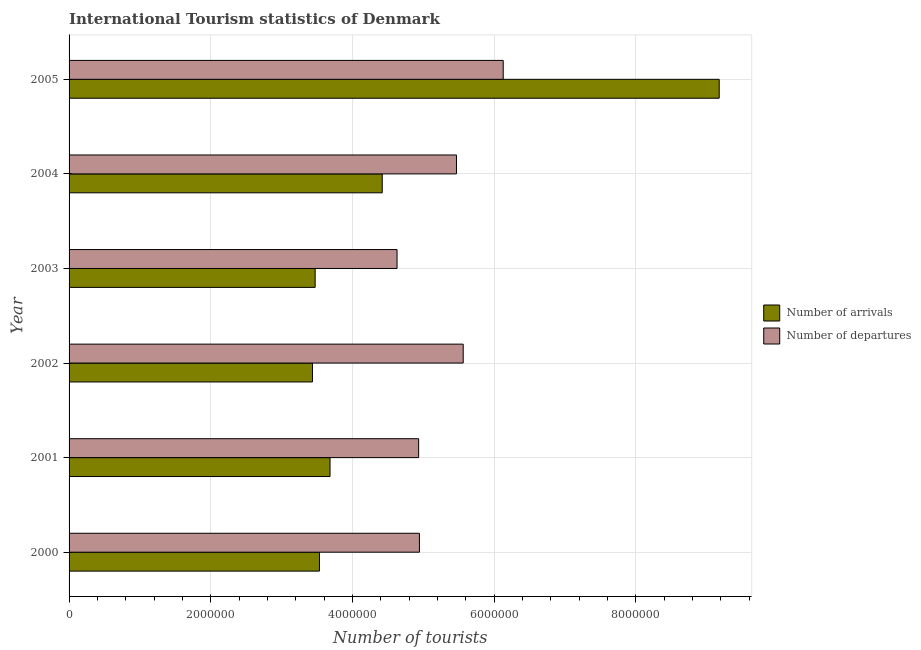How many different coloured bars are there?
Give a very brief answer. 2. Are the number of bars on each tick of the Y-axis equal?
Provide a succinct answer. Yes. What is the label of the 6th group of bars from the top?
Provide a succinct answer. 2000. What is the number of tourist departures in 2003?
Ensure brevity in your answer.  4.63e+06. Across all years, what is the maximum number of tourist arrivals?
Give a very brief answer. 9.18e+06. Across all years, what is the minimum number of tourist arrivals?
Offer a terse response. 3.44e+06. In which year was the number of tourist arrivals minimum?
Your answer should be compact. 2002. What is the total number of tourist arrivals in the graph?
Provide a short and direct response. 2.77e+07. What is the difference between the number of tourist departures in 2001 and that in 2002?
Your answer should be very brief. -6.29e+05. What is the difference between the number of tourist arrivals in 2005 and the number of tourist departures in 2003?
Offer a very short reply. 4.55e+06. What is the average number of tourist arrivals per year?
Make the answer very short. 4.62e+06. In the year 2004, what is the difference between the number of tourist departures and number of tourist arrivals?
Provide a short and direct response. 1.05e+06. What is the ratio of the number of tourist departures in 2000 to that in 2002?
Keep it short and to the point. 0.89. Is the number of tourist arrivals in 2000 less than that in 2003?
Your answer should be very brief. No. Is the difference between the number of tourist departures in 2000 and 2004 greater than the difference between the number of tourist arrivals in 2000 and 2004?
Offer a terse response. Yes. What is the difference between the highest and the second highest number of tourist departures?
Your response must be concise. 5.65e+05. What is the difference between the highest and the lowest number of tourist departures?
Give a very brief answer. 1.50e+06. What does the 1st bar from the top in 2000 represents?
Provide a short and direct response. Number of departures. What does the 2nd bar from the bottom in 2001 represents?
Provide a short and direct response. Number of departures. Are all the bars in the graph horizontal?
Ensure brevity in your answer.  Yes. Are the values on the major ticks of X-axis written in scientific E-notation?
Make the answer very short. No. Does the graph contain any zero values?
Offer a very short reply. No. Does the graph contain grids?
Keep it short and to the point. Yes. What is the title of the graph?
Your answer should be compact. International Tourism statistics of Denmark. What is the label or title of the X-axis?
Keep it short and to the point. Number of tourists. What is the Number of tourists of Number of arrivals in 2000?
Give a very brief answer. 3.54e+06. What is the Number of tourists of Number of departures in 2000?
Offer a very short reply. 4.95e+06. What is the Number of tourists in Number of arrivals in 2001?
Provide a short and direct response. 3.68e+06. What is the Number of tourists in Number of departures in 2001?
Offer a terse response. 4.94e+06. What is the Number of tourists in Number of arrivals in 2002?
Keep it short and to the point. 3.44e+06. What is the Number of tourists in Number of departures in 2002?
Make the answer very short. 5.56e+06. What is the Number of tourists of Number of arrivals in 2003?
Provide a short and direct response. 3.47e+06. What is the Number of tourists of Number of departures in 2003?
Your response must be concise. 4.63e+06. What is the Number of tourists in Number of arrivals in 2004?
Provide a short and direct response. 4.42e+06. What is the Number of tourists in Number of departures in 2004?
Make the answer very short. 5.47e+06. What is the Number of tourists in Number of arrivals in 2005?
Offer a very short reply. 9.18e+06. What is the Number of tourists of Number of departures in 2005?
Provide a short and direct response. 6.13e+06. Across all years, what is the maximum Number of tourists of Number of arrivals?
Provide a succinct answer. 9.18e+06. Across all years, what is the maximum Number of tourists in Number of departures?
Your response must be concise. 6.13e+06. Across all years, what is the minimum Number of tourists in Number of arrivals?
Make the answer very short. 3.44e+06. Across all years, what is the minimum Number of tourists in Number of departures?
Provide a succinct answer. 4.63e+06. What is the total Number of tourists in Number of arrivals in the graph?
Provide a succinct answer. 2.77e+07. What is the total Number of tourists of Number of departures in the graph?
Ensure brevity in your answer.  3.17e+07. What is the difference between the Number of tourists of Number of arrivals in 2000 and that in 2001?
Offer a very short reply. -1.49e+05. What is the difference between the Number of tourists of Number of departures in 2000 and that in 2001?
Ensure brevity in your answer.  1.10e+04. What is the difference between the Number of tourists of Number of arrivals in 2000 and that in 2002?
Provide a succinct answer. 9.90e+04. What is the difference between the Number of tourists of Number of departures in 2000 and that in 2002?
Keep it short and to the point. -6.18e+05. What is the difference between the Number of tourists in Number of arrivals in 2000 and that in 2003?
Provide a short and direct response. 6.10e+04. What is the difference between the Number of tourists of Number of departures in 2000 and that in 2003?
Provide a succinct answer. 3.16e+05. What is the difference between the Number of tourists in Number of arrivals in 2000 and that in 2004?
Give a very brief answer. -8.86e+05. What is the difference between the Number of tourists of Number of departures in 2000 and that in 2004?
Ensure brevity in your answer.  -5.23e+05. What is the difference between the Number of tourists of Number of arrivals in 2000 and that in 2005?
Ensure brevity in your answer.  -5.64e+06. What is the difference between the Number of tourists of Number of departures in 2000 and that in 2005?
Keep it short and to the point. -1.18e+06. What is the difference between the Number of tourists of Number of arrivals in 2001 and that in 2002?
Your response must be concise. 2.48e+05. What is the difference between the Number of tourists in Number of departures in 2001 and that in 2002?
Your response must be concise. -6.29e+05. What is the difference between the Number of tourists in Number of departures in 2001 and that in 2003?
Ensure brevity in your answer.  3.05e+05. What is the difference between the Number of tourists in Number of arrivals in 2001 and that in 2004?
Offer a terse response. -7.37e+05. What is the difference between the Number of tourists in Number of departures in 2001 and that in 2004?
Keep it short and to the point. -5.34e+05. What is the difference between the Number of tourists of Number of arrivals in 2001 and that in 2005?
Offer a terse response. -5.49e+06. What is the difference between the Number of tourists in Number of departures in 2001 and that in 2005?
Offer a terse response. -1.19e+06. What is the difference between the Number of tourists in Number of arrivals in 2002 and that in 2003?
Offer a terse response. -3.80e+04. What is the difference between the Number of tourists in Number of departures in 2002 and that in 2003?
Your answer should be compact. 9.34e+05. What is the difference between the Number of tourists in Number of arrivals in 2002 and that in 2004?
Give a very brief answer. -9.85e+05. What is the difference between the Number of tourists of Number of departures in 2002 and that in 2004?
Provide a short and direct response. 9.50e+04. What is the difference between the Number of tourists of Number of arrivals in 2002 and that in 2005?
Your answer should be compact. -5.74e+06. What is the difference between the Number of tourists of Number of departures in 2002 and that in 2005?
Offer a terse response. -5.65e+05. What is the difference between the Number of tourists in Number of arrivals in 2003 and that in 2004?
Give a very brief answer. -9.47e+05. What is the difference between the Number of tourists of Number of departures in 2003 and that in 2004?
Ensure brevity in your answer.  -8.39e+05. What is the difference between the Number of tourists in Number of arrivals in 2003 and that in 2005?
Keep it short and to the point. -5.70e+06. What is the difference between the Number of tourists of Number of departures in 2003 and that in 2005?
Offer a very short reply. -1.50e+06. What is the difference between the Number of tourists in Number of arrivals in 2004 and that in 2005?
Ensure brevity in your answer.  -4.76e+06. What is the difference between the Number of tourists in Number of departures in 2004 and that in 2005?
Offer a very short reply. -6.60e+05. What is the difference between the Number of tourists in Number of arrivals in 2000 and the Number of tourists in Number of departures in 2001?
Your response must be concise. -1.40e+06. What is the difference between the Number of tourists in Number of arrivals in 2000 and the Number of tourists in Number of departures in 2002?
Ensure brevity in your answer.  -2.03e+06. What is the difference between the Number of tourists in Number of arrivals in 2000 and the Number of tourists in Number of departures in 2003?
Give a very brief answer. -1.10e+06. What is the difference between the Number of tourists of Number of arrivals in 2000 and the Number of tourists of Number of departures in 2004?
Give a very brief answer. -1.93e+06. What is the difference between the Number of tourists in Number of arrivals in 2000 and the Number of tourists in Number of departures in 2005?
Your answer should be very brief. -2.59e+06. What is the difference between the Number of tourists of Number of arrivals in 2001 and the Number of tourists of Number of departures in 2002?
Provide a succinct answer. -1.88e+06. What is the difference between the Number of tourists of Number of arrivals in 2001 and the Number of tourists of Number of departures in 2003?
Keep it short and to the point. -9.46e+05. What is the difference between the Number of tourists of Number of arrivals in 2001 and the Number of tourists of Number of departures in 2004?
Offer a terse response. -1.78e+06. What is the difference between the Number of tourists of Number of arrivals in 2001 and the Number of tourists of Number of departures in 2005?
Your answer should be very brief. -2.44e+06. What is the difference between the Number of tourists in Number of arrivals in 2002 and the Number of tourists in Number of departures in 2003?
Make the answer very short. -1.19e+06. What is the difference between the Number of tourists of Number of arrivals in 2002 and the Number of tourists of Number of departures in 2004?
Provide a succinct answer. -2.03e+06. What is the difference between the Number of tourists of Number of arrivals in 2002 and the Number of tourists of Number of departures in 2005?
Keep it short and to the point. -2.69e+06. What is the difference between the Number of tourists in Number of arrivals in 2003 and the Number of tourists in Number of departures in 2004?
Provide a succinct answer. -2.00e+06. What is the difference between the Number of tourists of Number of arrivals in 2003 and the Number of tourists of Number of departures in 2005?
Make the answer very short. -2.66e+06. What is the difference between the Number of tourists of Number of arrivals in 2004 and the Number of tourists of Number of departures in 2005?
Provide a succinct answer. -1.71e+06. What is the average Number of tourists of Number of arrivals per year?
Offer a very short reply. 4.62e+06. What is the average Number of tourists of Number of departures per year?
Keep it short and to the point. 5.28e+06. In the year 2000, what is the difference between the Number of tourists of Number of arrivals and Number of tourists of Number of departures?
Offer a very short reply. -1.41e+06. In the year 2001, what is the difference between the Number of tourists in Number of arrivals and Number of tourists in Number of departures?
Your response must be concise. -1.25e+06. In the year 2002, what is the difference between the Number of tourists of Number of arrivals and Number of tourists of Number of departures?
Ensure brevity in your answer.  -2.13e+06. In the year 2003, what is the difference between the Number of tourists in Number of arrivals and Number of tourists in Number of departures?
Your answer should be compact. -1.16e+06. In the year 2004, what is the difference between the Number of tourists in Number of arrivals and Number of tourists in Number of departures?
Ensure brevity in your answer.  -1.05e+06. In the year 2005, what is the difference between the Number of tourists in Number of arrivals and Number of tourists in Number of departures?
Offer a very short reply. 3.05e+06. What is the ratio of the Number of tourists in Number of arrivals in 2000 to that in 2001?
Your response must be concise. 0.96. What is the ratio of the Number of tourists of Number of arrivals in 2000 to that in 2002?
Offer a terse response. 1.03. What is the ratio of the Number of tourists of Number of arrivals in 2000 to that in 2003?
Offer a terse response. 1.02. What is the ratio of the Number of tourists in Number of departures in 2000 to that in 2003?
Provide a succinct answer. 1.07. What is the ratio of the Number of tourists of Number of arrivals in 2000 to that in 2004?
Provide a succinct answer. 0.8. What is the ratio of the Number of tourists of Number of departures in 2000 to that in 2004?
Your response must be concise. 0.9. What is the ratio of the Number of tourists in Number of arrivals in 2000 to that in 2005?
Provide a short and direct response. 0.39. What is the ratio of the Number of tourists of Number of departures in 2000 to that in 2005?
Give a very brief answer. 0.81. What is the ratio of the Number of tourists of Number of arrivals in 2001 to that in 2002?
Your answer should be compact. 1.07. What is the ratio of the Number of tourists in Number of departures in 2001 to that in 2002?
Your answer should be very brief. 0.89. What is the ratio of the Number of tourists of Number of arrivals in 2001 to that in 2003?
Offer a very short reply. 1.06. What is the ratio of the Number of tourists of Number of departures in 2001 to that in 2003?
Offer a terse response. 1.07. What is the ratio of the Number of tourists in Number of departures in 2001 to that in 2004?
Make the answer very short. 0.9. What is the ratio of the Number of tourists in Number of arrivals in 2001 to that in 2005?
Offer a terse response. 0.4. What is the ratio of the Number of tourists of Number of departures in 2001 to that in 2005?
Offer a very short reply. 0.81. What is the ratio of the Number of tourists in Number of departures in 2002 to that in 2003?
Give a very brief answer. 1.2. What is the ratio of the Number of tourists of Number of arrivals in 2002 to that in 2004?
Provide a succinct answer. 0.78. What is the ratio of the Number of tourists of Number of departures in 2002 to that in 2004?
Keep it short and to the point. 1.02. What is the ratio of the Number of tourists in Number of arrivals in 2002 to that in 2005?
Provide a succinct answer. 0.37. What is the ratio of the Number of tourists of Number of departures in 2002 to that in 2005?
Your answer should be very brief. 0.91. What is the ratio of the Number of tourists of Number of arrivals in 2003 to that in 2004?
Offer a terse response. 0.79. What is the ratio of the Number of tourists in Number of departures in 2003 to that in 2004?
Ensure brevity in your answer.  0.85. What is the ratio of the Number of tourists of Number of arrivals in 2003 to that in 2005?
Keep it short and to the point. 0.38. What is the ratio of the Number of tourists in Number of departures in 2003 to that in 2005?
Provide a short and direct response. 0.76. What is the ratio of the Number of tourists of Number of arrivals in 2004 to that in 2005?
Offer a terse response. 0.48. What is the ratio of the Number of tourists of Number of departures in 2004 to that in 2005?
Offer a very short reply. 0.89. What is the difference between the highest and the second highest Number of tourists in Number of arrivals?
Your answer should be very brief. 4.76e+06. What is the difference between the highest and the second highest Number of tourists in Number of departures?
Give a very brief answer. 5.65e+05. What is the difference between the highest and the lowest Number of tourists in Number of arrivals?
Offer a very short reply. 5.74e+06. What is the difference between the highest and the lowest Number of tourists in Number of departures?
Make the answer very short. 1.50e+06. 